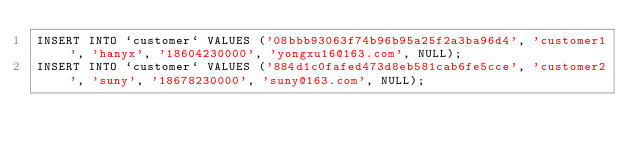<code> <loc_0><loc_0><loc_500><loc_500><_SQL_>INSERT INTO `customer` VALUES ('08bbb93063f74b96b95a25f2a3ba96d4', 'customer1', 'hanyx', '18604230000', 'yongxu16@163.com', NULL);
INSERT INTO `customer` VALUES ('884d1c0fafed473d8eb581cab6fe5cce', 'customer2', 'suny', '18678230000', 'suny@163.com', NULL);</code> 